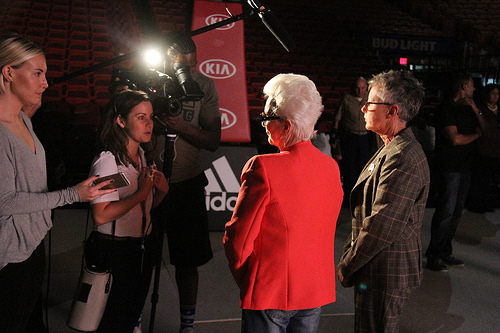<image>
Is there a woman behind the man? No. The woman is not behind the man. From this viewpoint, the woman appears to be positioned elsewhere in the scene. Is the woman to the right of the camera? Yes. From this viewpoint, the woman is positioned to the right side relative to the camera. 